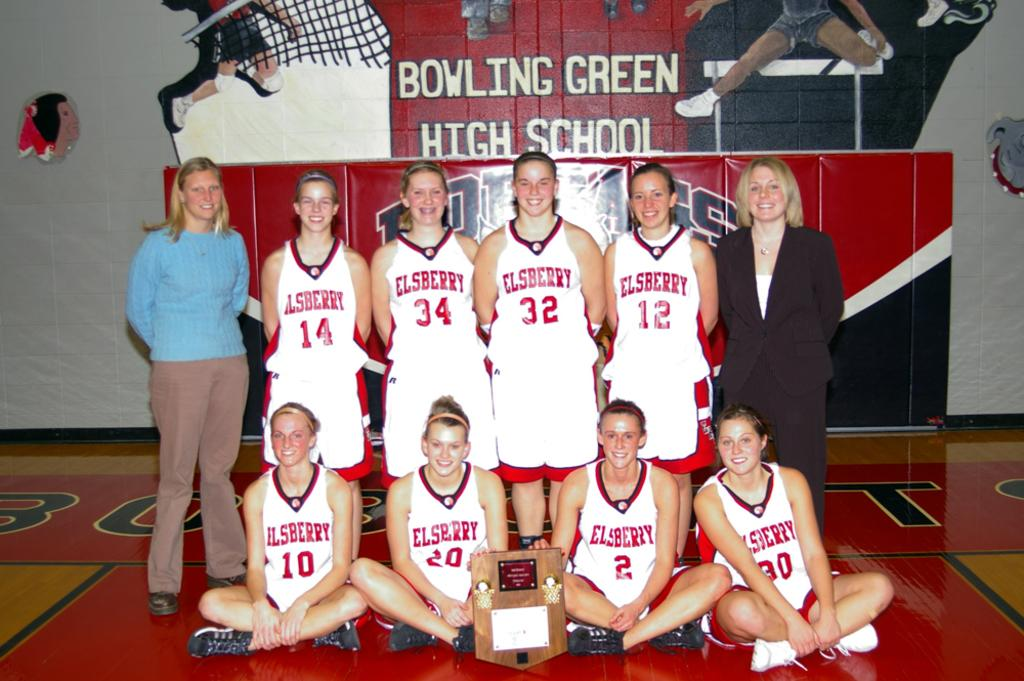<image>
Summarize the visual content of the image. A team is taking a picture in a gym at Bowling Green High School. 